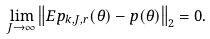Convert formula to latex. <formula><loc_0><loc_0><loc_500><loc_500>\lim _ { J \rightarrow \infty } \left \| E p _ { k , J , r } ( \theta ) - p ( \theta ) \right \| _ { 2 } = 0 .</formula> 